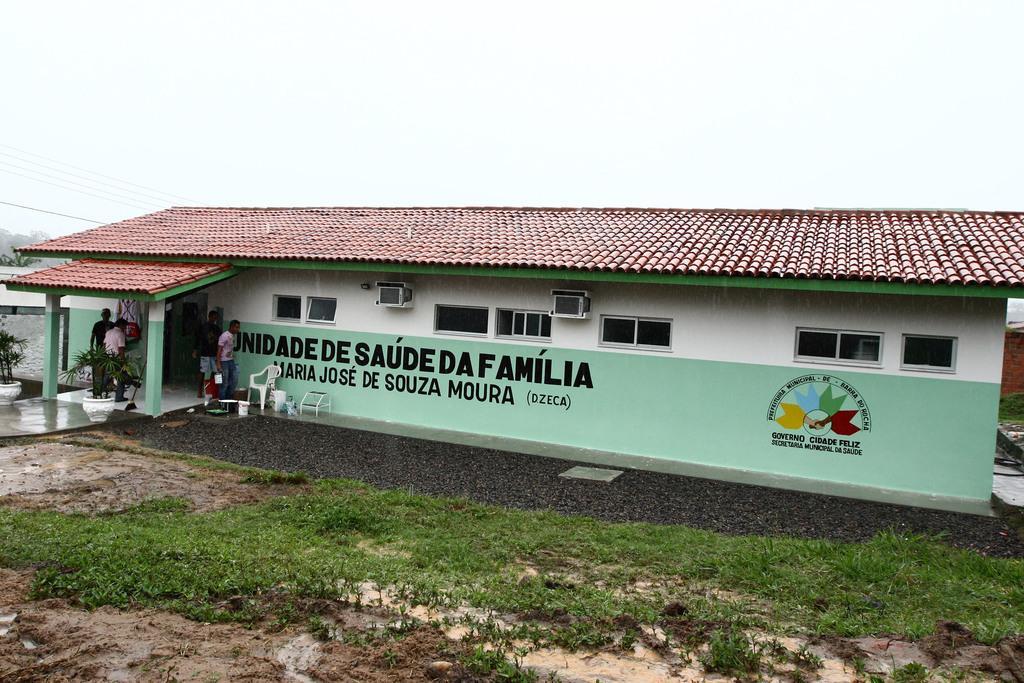In one or two sentences, can you explain what this image depicts? In this picture we can see a house, we can see few people are standing at the entrances, side we can see some grass. 